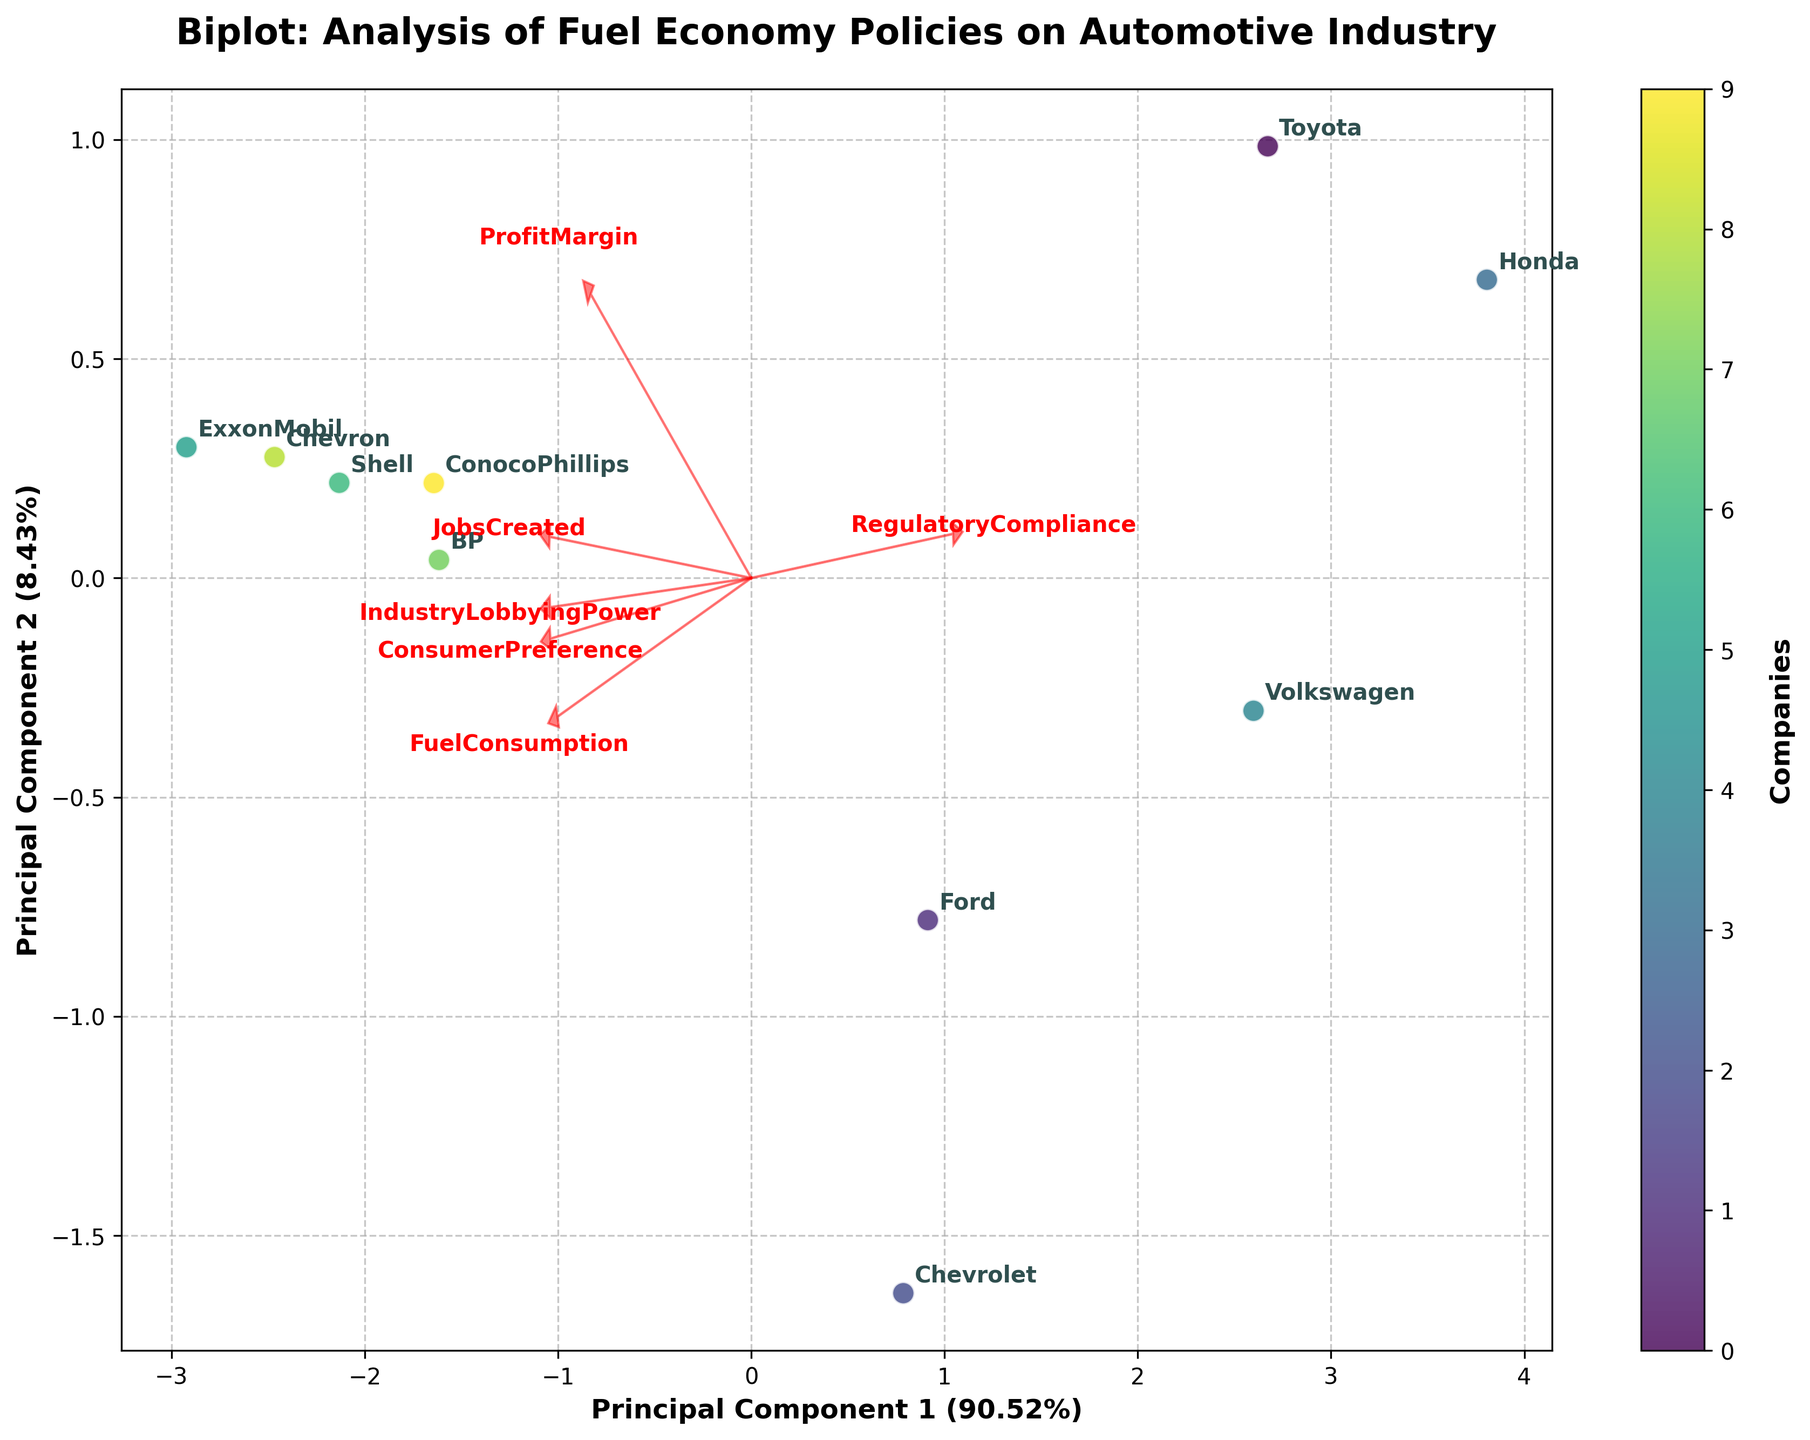How many principal components are displayed in the biplot? The biplot shows two principal components as indicated by the two axes labeled "Principal Component 1" and "Principal Component 2"
Answer: Two What percentage of variation is explained by Principal Component 1? The label on the x-axis of Principal Component 1 shows the explained variance percentage. From the figure, we can see the explained variance ratio is displayed in parentheses next to the axis title.
Answer: Refer to the exact number shown on the figure Which company has the highest value along Principal Component 1? We need to look at the position of the companies along the x-axis (Principal Component 1). The company farthest to the right on this axis has the highest value along Principal Component 1.
Answer: Refer to the company name shown on the rightmost side of Principal Component 1 What is the relationship between "Fuel Consumption" and "Jobs Created" based on the direction of the loading vectors? The loading vectors for "Fuel Consumption" and "Jobs Created" need to be checked for their relative directions. If they point in the same direction, these variables are positively related. If they point in opposite directions, they are negatively related.
Answer: Refer to the direction of the loading vectors for "Fuel Consumption" and "Jobs Created" Which variable is most strongly aligned with Principal Component 2? The variable that has the longest loading vector projection onto the y-axis (Principal Component 2) is most strongly aligned with this principal component.
Answer: Refer to the variable with the longest projection on Principal Component 2 How does "Consumer Preference" correlate with "Profit Margin"? We should check the loading vectors of both "Consumer Preference" and "Profit Margin". If they point in similar directions, they have a positive correlation; if they point in opposite directions, they have a negative correlation.
Answer: Refer to the direction of the loading vectors for "Consumer Preference" and "Profit Margin" Out of Chevron and BP, which company has a higher value on Principal Component 2? By looking at the positions of Chevron and BP along the y-axis (Principal Component 2), the company that is higher along this axis has the higher value in Principal Component 2.
Answer: Refer to the relative position of Chevron and BP on the y-axis What do the arrows represent in this biplot? The arrows, or loading vectors, represent the direction and magnitude of each variable's contribution to the principal components. The length of the arrows indicates the strength of the variable’s effect.
Answer: Loading vectors for variables Is there a significant separation between automotive companies and oil companies in the biplot? By examining the clustering of dots (representing companies) in the plot, we can determine if there is a significant visual separation (clustering) between the categories of companies.
Answer: Refer to the clustering pattern of automotive companies vs. oil companies Which variable seems least influential in distinguishing the companies in the biplot? The variable with the shortest loading vector would have the least influence on distinguishing the companies in the biplot as it contributes least to the principal components.
Answer: Refer to the variable with the shortest loading vector 